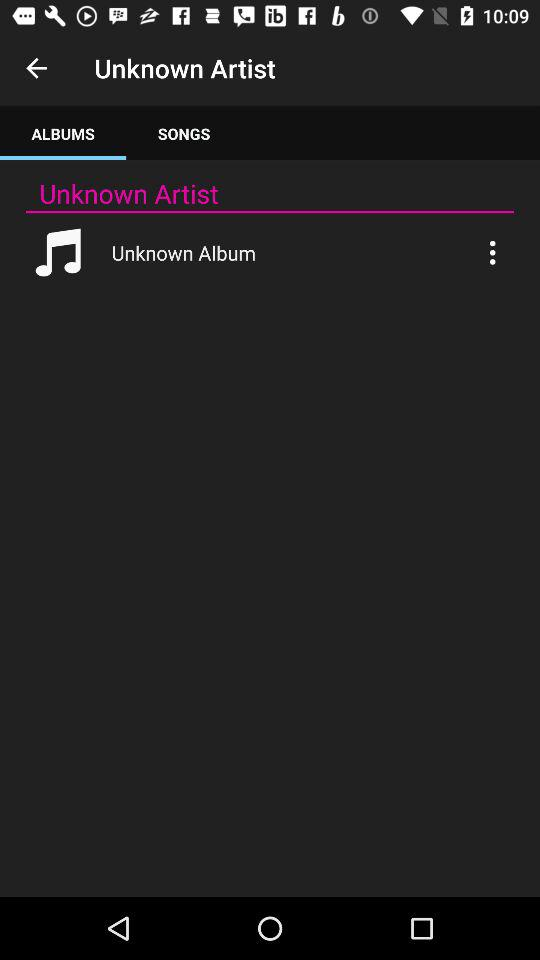Which tab is selected?
When the provided information is insufficient, respond with <no answer>. <no answer> 